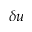Convert formula to latex. <formula><loc_0><loc_0><loc_500><loc_500>\delta u</formula> 